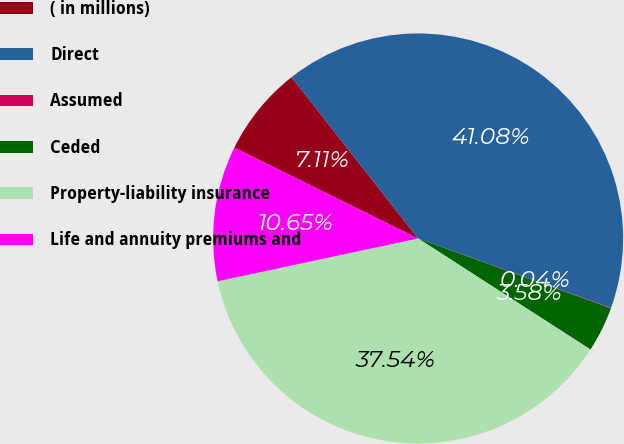Convert chart. <chart><loc_0><loc_0><loc_500><loc_500><pie_chart><fcel>( in millions)<fcel>Direct<fcel>Assumed<fcel>Ceded<fcel>Property-liability insurance<fcel>Life and annuity premiums and<nl><fcel>7.11%<fcel>41.08%<fcel>0.04%<fcel>3.58%<fcel>37.54%<fcel>10.65%<nl></chart> 